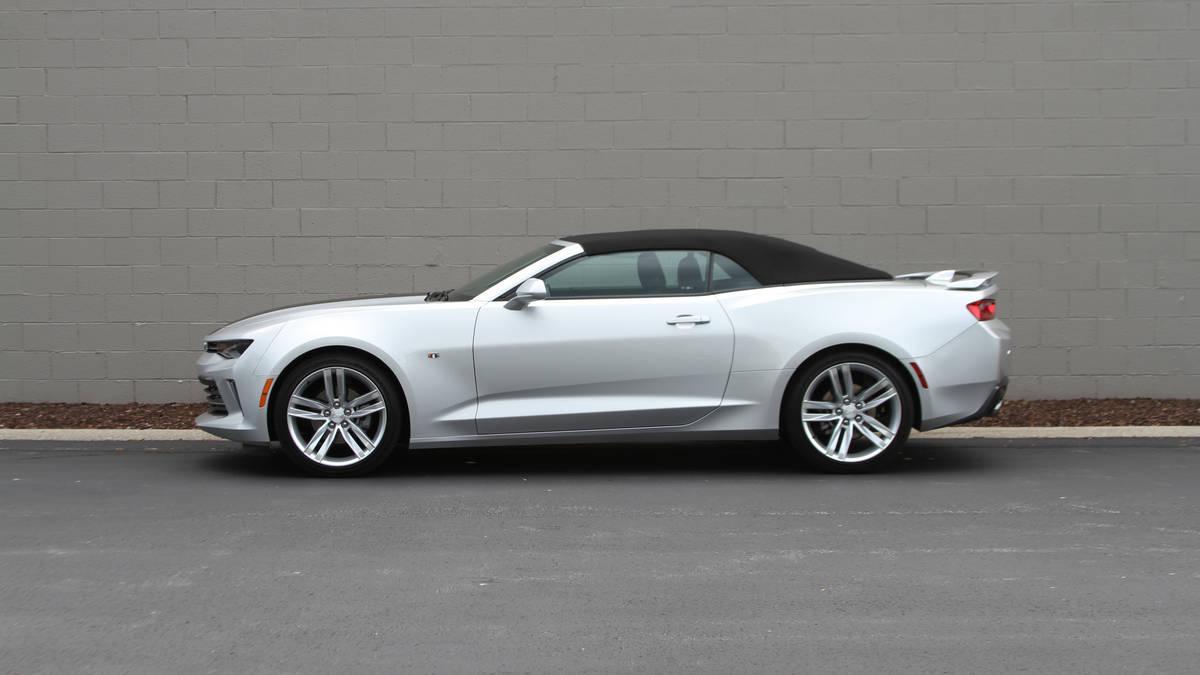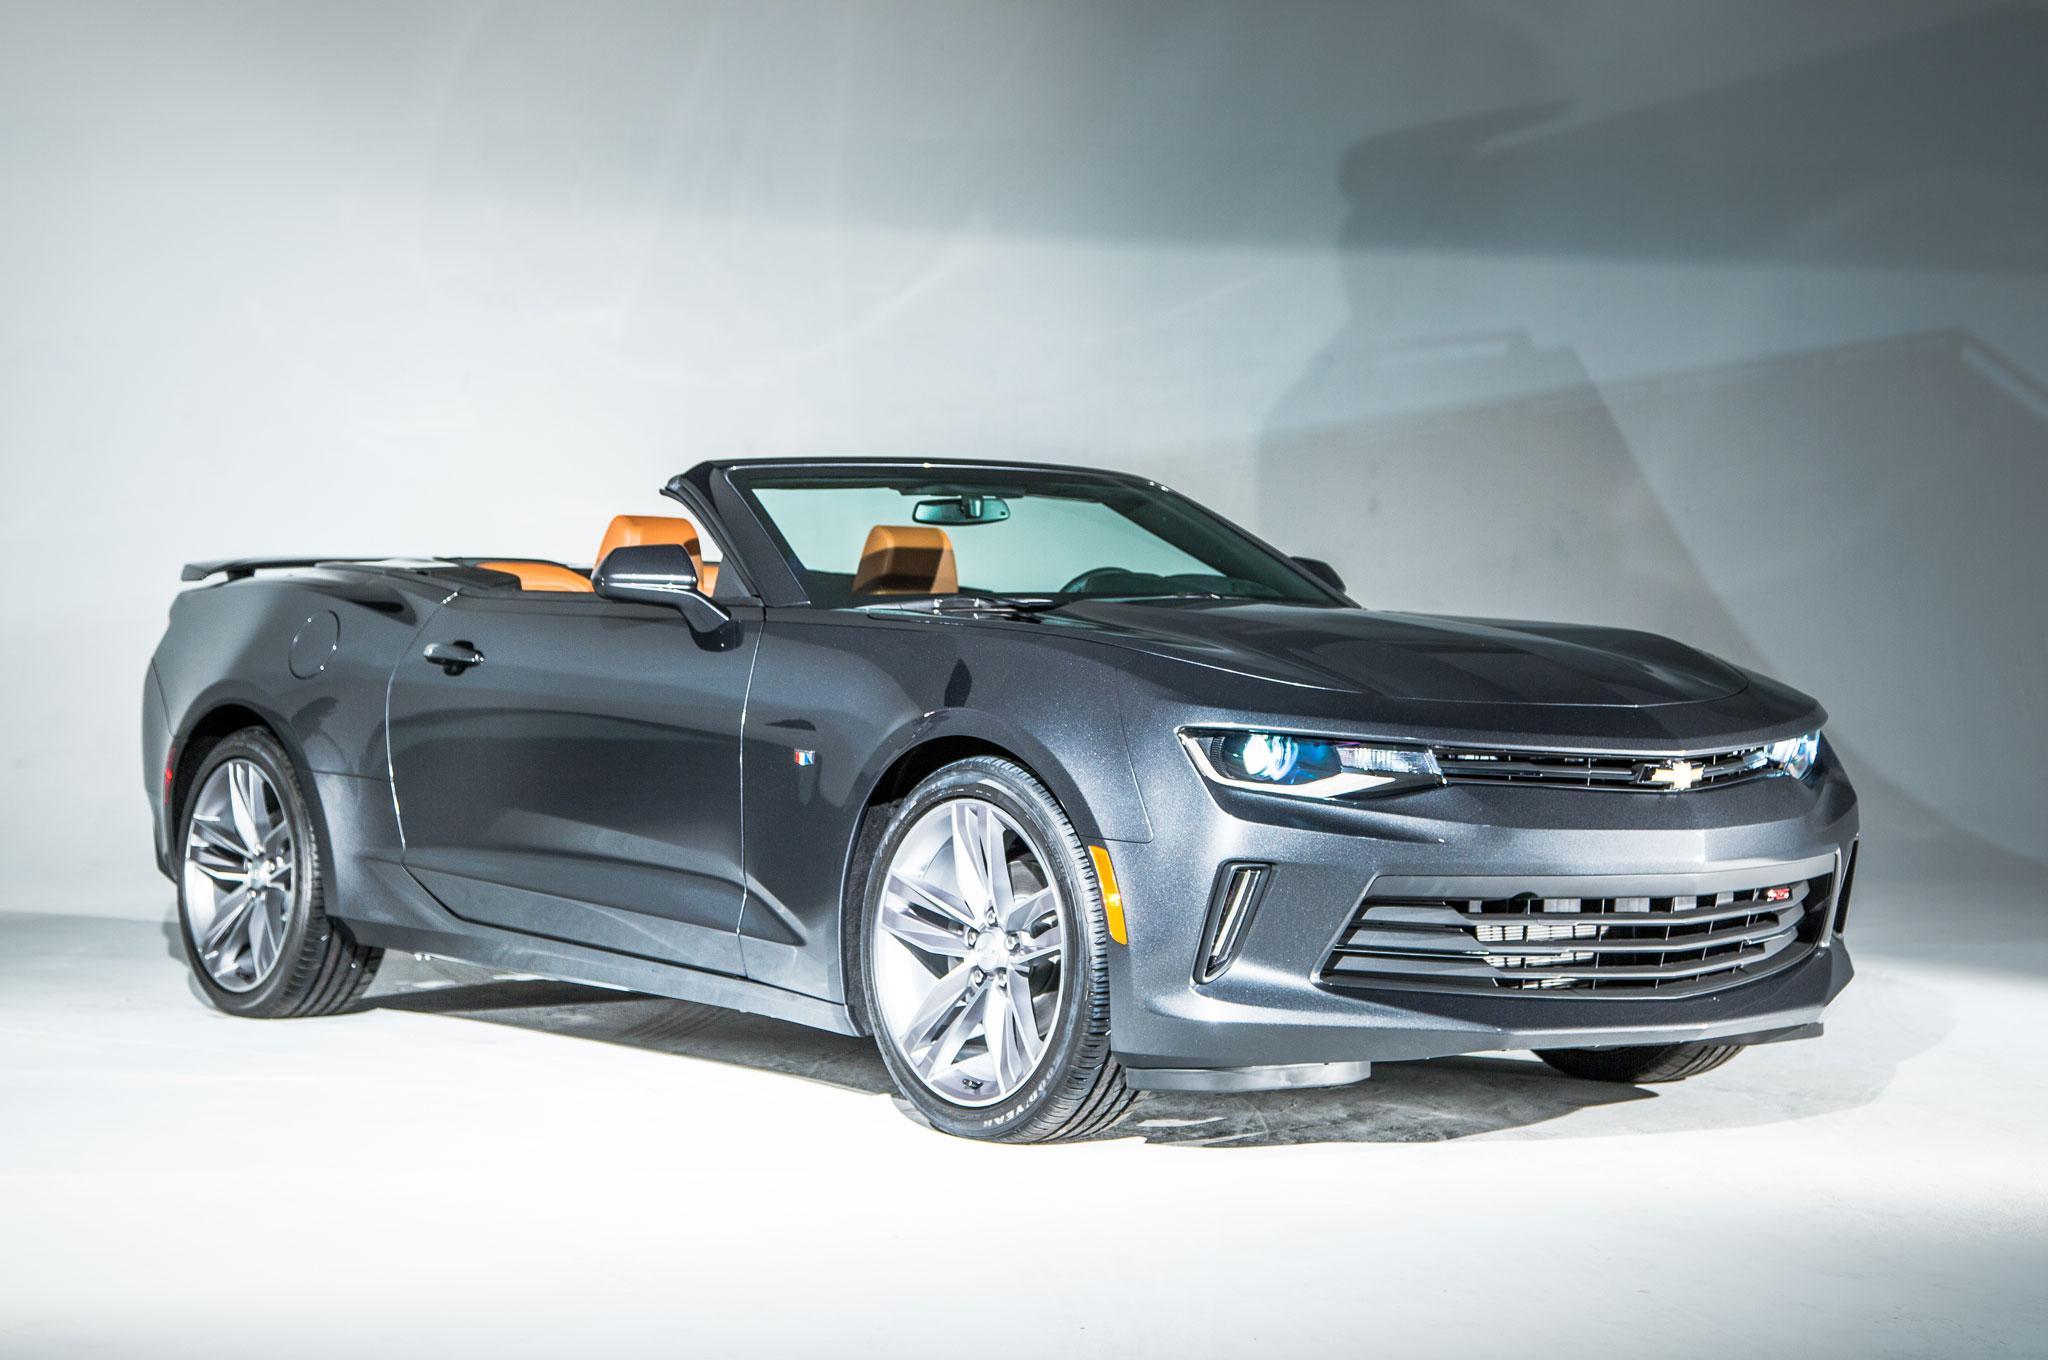The first image is the image on the left, the second image is the image on the right. Assess this claim about the two images: "An image shows an angled white convertible with top down in an outdoor scene.". Correct or not? Answer yes or no. No. 